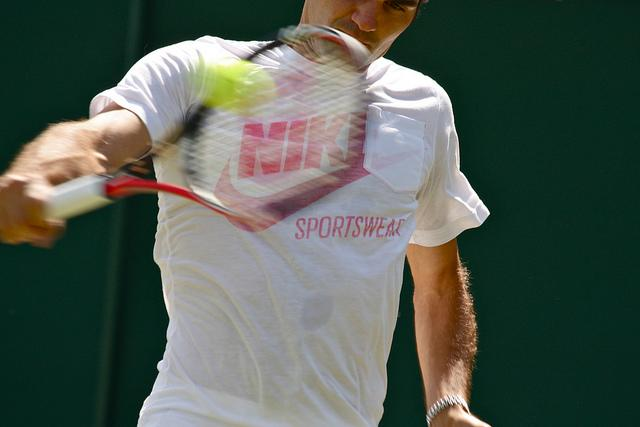Which country houses the headquarter of the brand company manufacturing the man's shirt? Please explain your reasoning. united states. This is the country it is based in 